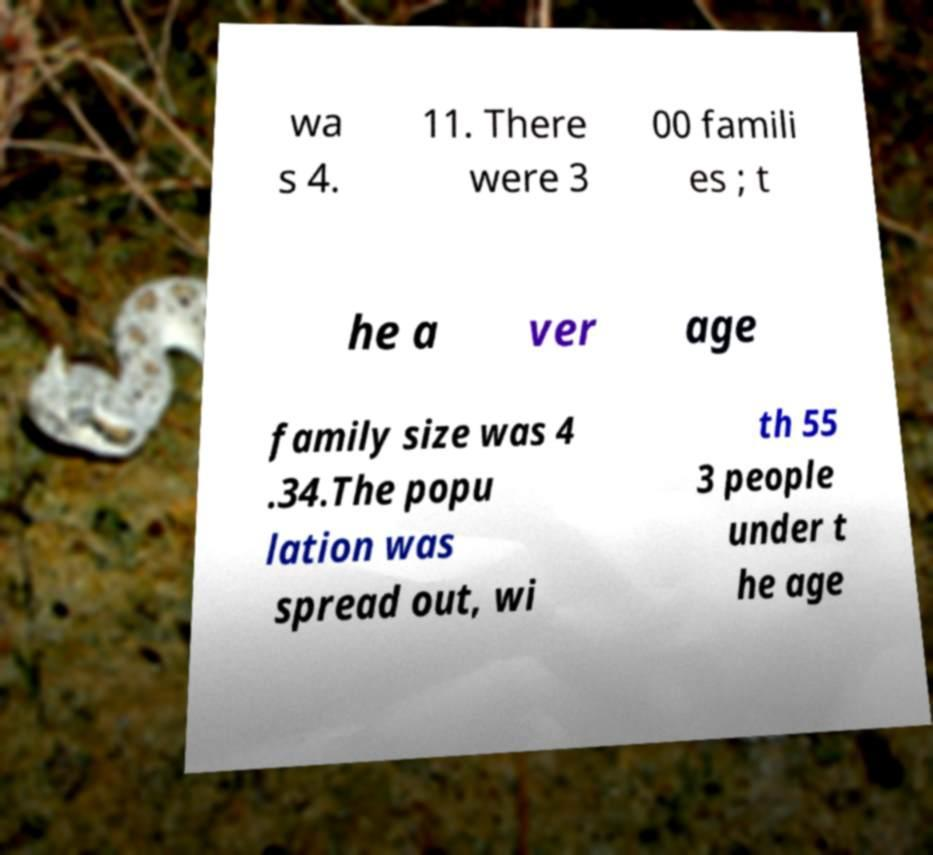Could you assist in decoding the text presented in this image and type it out clearly? wa s 4. 11. There were 3 00 famili es ; t he a ver age family size was 4 .34.The popu lation was spread out, wi th 55 3 people under t he age 